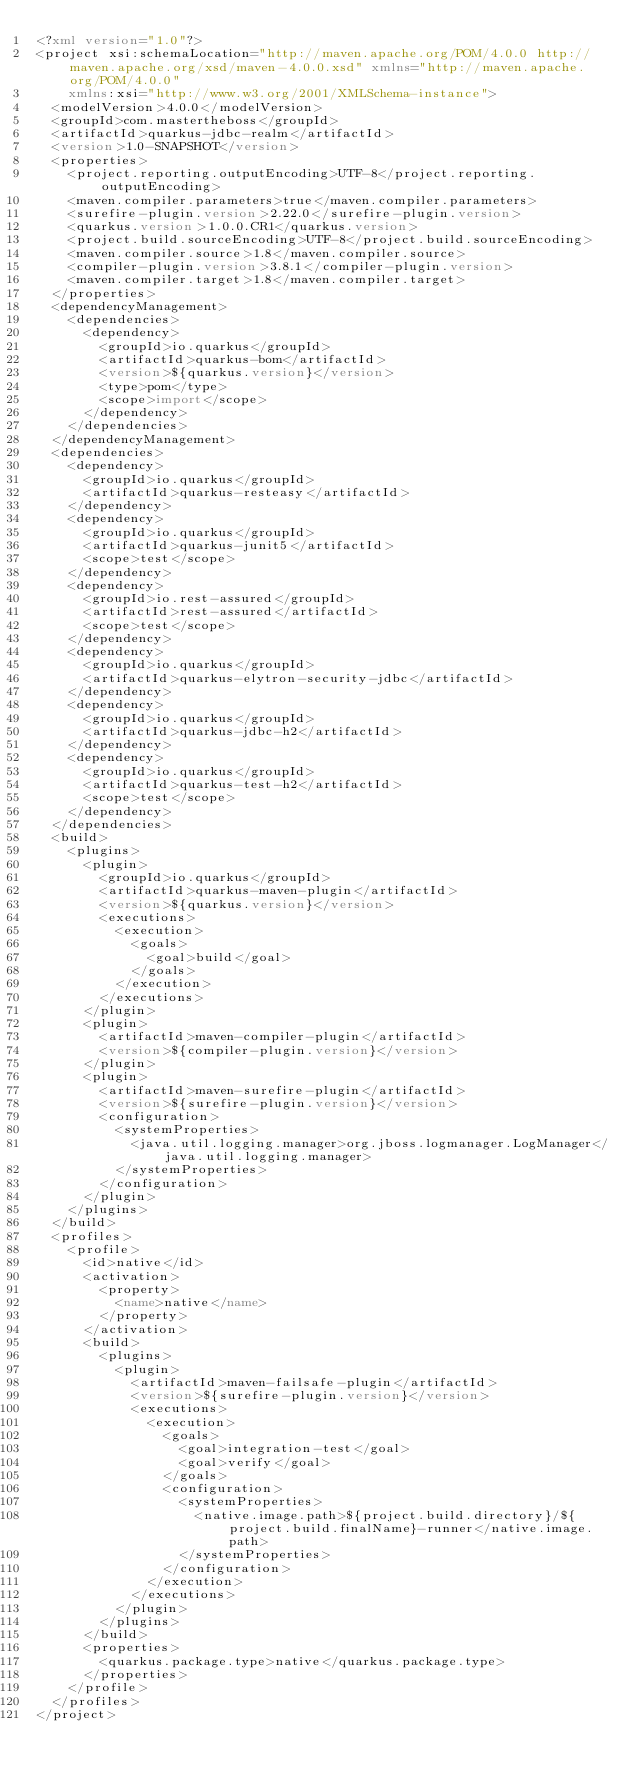<code> <loc_0><loc_0><loc_500><loc_500><_XML_><?xml version="1.0"?>
<project xsi:schemaLocation="http://maven.apache.org/POM/4.0.0 http://maven.apache.org/xsd/maven-4.0.0.xsd" xmlns="http://maven.apache.org/POM/4.0.0"
    xmlns:xsi="http://www.w3.org/2001/XMLSchema-instance">
  <modelVersion>4.0.0</modelVersion>
  <groupId>com.mastertheboss</groupId>
  <artifactId>quarkus-jdbc-realm</artifactId>
  <version>1.0-SNAPSHOT</version>
  <properties>
    <project.reporting.outputEncoding>UTF-8</project.reporting.outputEncoding>
    <maven.compiler.parameters>true</maven.compiler.parameters>
    <surefire-plugin.version>2.22.0</surefire-plugin.version>
    <quarkus.version>1.0.0.CR1</quarkus.version>
    <project.build.sourceEncoding>UTF-8</project.build.sourceEncoding>
    <maven.compiler.source>1.8</maven.compiler.source>
    <compiler-plugin.version>3.8.1</compiler-plugin.version>
    <maven.compiler.target>1.8</maven.compiler.target>
  </properties>
  <dependencyManagement>
    <dependencies>
      <dependency>
        <groupId>io.quarkus</groupId>
        <artifactId>quarkus-bom</artifactId>
        <version>${quarkus.version}</version>
        <type>pom</type>
        <scope>import</scope>
      </dependency>
    </dependencies>
  </dependencyManagement>
  <dependencies>
    <dependency>
      <groupId>io.quarkus</groupId>
      <artifactId>quarkus-resteasy</artifactId>
    </dependency>
    <dependency>
      <groupId>io.quarkus</groupId>
      <artifactId>quarkus-junit5</artifactId>
      <scope>test</scope>
    </dependency>
    <dependency>
      <groupId>io.rest-assured</groupId>
      <artifactId>rest-assured</artifactId>
      <scope>test</scope>
    </dependency>
    <dependency>
      <groupId>io.quarkus</groupId>
      <artifactId>quarkus-elytron-security-jdbc</artifactId>
    </dependency>
    <dependency>
      <groupId>io.quarkus</groupId>
      <artifactId>quarkus-jdbc-h2</artifactId>
    </dependency>
    <dependency>
      <groupId>io.quarkus</groupId>
      <artifactId>quarkus-test-h2</artifactId>
      <scope>test</scope>
    </dependency>
  </dependencies>
  <build>
    <plugins>
      <plugin>
        <groupId>io.quarkus</groupId>
        <artifactId>quarkus-maven-plugin</artifactId>
        <version>${quarkus.version}</version>
        <executions>
          <execution>
            <goals>
              <goal>build</goal>
            </goals>
          </execution>
        </executions>
      </plugin>
      <plugin>
        <artifactId>maven-compiler-plugin</artifactId>
        <version>${compiler-plugin.version}</version>
      </plugin>
      <plugin>
        <artifactId>maven-surefire-plugin</artifactId>
        <version>${surefire-plugin.version}</version>
        <configuration>
          <systemProperties>
            <java.util.logging.manager>org.jboss.logmanager.LogManager</java.util.logging.manager>
          </systemProperties>
        </configuration>
      </plugin>
    </plugins>
  </build>
  <profiles>
    <profile>
      <id>native</id>
      <activation>
        <property>
          <name>native</name>
        </property>
      </activation>
      <build>
        <plugins>
          <plugin>
            <artifactId>maven-failsafe-plugin</artifactId>
            <version>${surefire-plugin.version}</version>
            <executions>
              <execution>
                <goals>
                  <goal>integration-test</goal>
                  <goal>verify</goal>
                </goals>
                <configuration>
                  <systemProperties>
                    <native.image.path>${project.build.directory}/${project.build.finalName}-runner</native.image.path>
                  </systemProperties>
                </configuration>
              </execution>
            </executions>
          </plugin>
        </plugins>
      </build>
      <properties>
        <quarkus.package.type>native</quarkus.package.type>
      </properties>
    </profile>
  </profiles>
</project>
</code> 